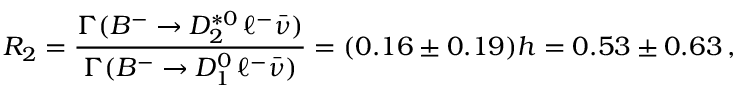<formula> <loc_0><loc_0><loc_500><loc_500>R _ { 2 } = \frac { \Gamma ( B ^ { - } \to D _ { 2 } ^ { * 0 } \, \ell ^ { - } \bar { \nu } ) } { \Gamma ( B ^ { - } \to D _ { 1 } ^ { 0 } \, \ell ^ { - } \bar { \nu } ) } = ( 0 . 1 6 \pm 0 . 1 9 ) h = 0 . 5 3 \pm 0 . 6 3 \, ,</formula> 